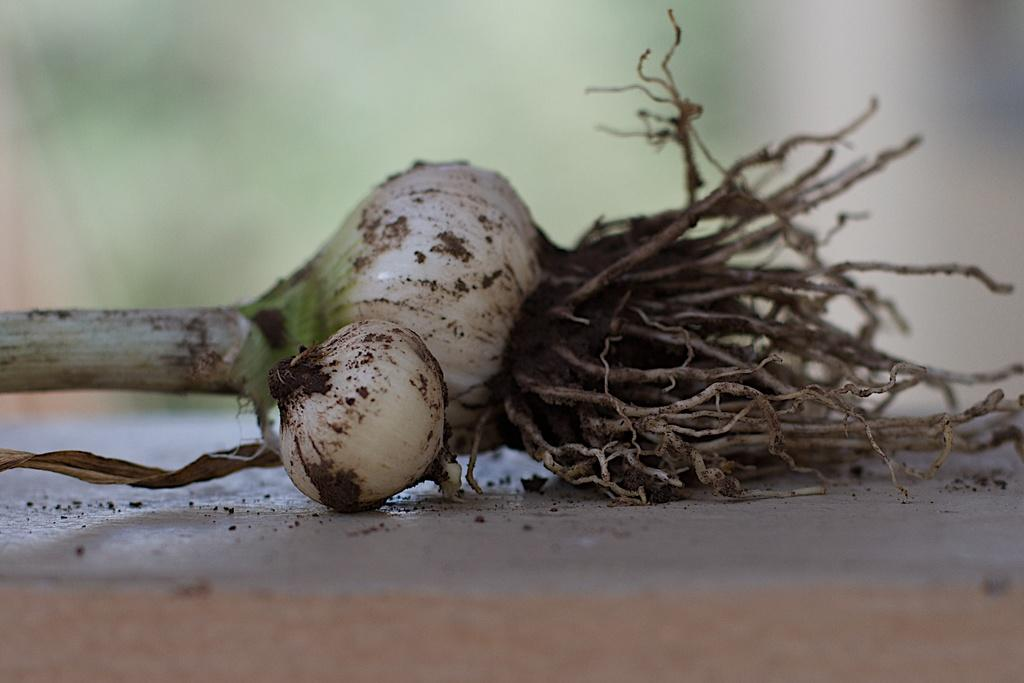What type of vegetable is present in the image? There are onions in the image. Where are the onions located? The onions are placed on a table. How are the onions positioned on the table? The onions are in the center of the image. What type of water feature can be seen in the image? There is no water feature present in the image; it features onions on a table. Can you tell me which verse from a book is being referenced in the image? There is no reference to a book or verse in the image; it features onions on a table. 